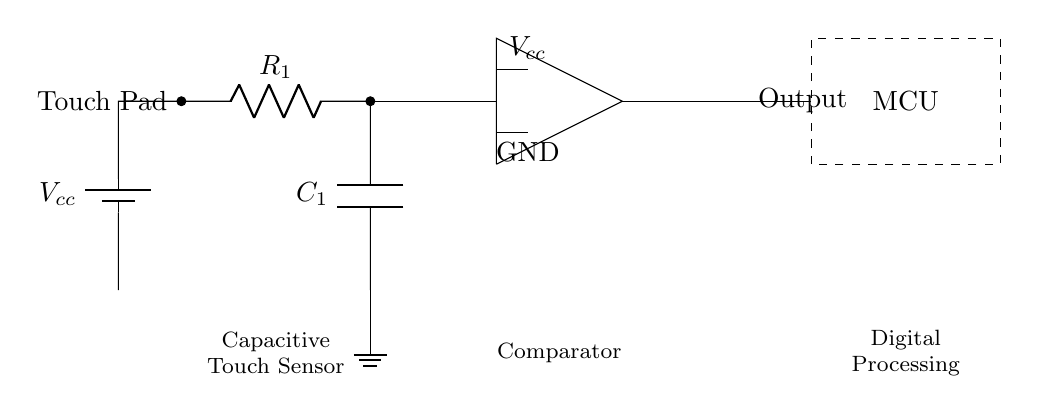What is the function of the touch pad? The touch pad acts as the input interface for the capacitive touch sensor, allowing users to interact with the digital book.
Answer: input interface What component is labeled as C1? C1 is a capacitor in the circuit, which is used to store electrical energy and help in sensing changes in capacitance when a finger comes close to the touch pad.
Answer: capacitor How many resistors are in this circuit? There is one resistor labeled R1 in the circuit, which is used to limit the flow of current.
Answer: one What is connected to the ground in the circuit? The ground is connected to the lower terminal of the capacitor C1 and is a common return path for electric current.
Answer: lower terminal of capacitor What does the numerical label on Vcc indicate? Vcc provides the necessary voltage supply for the circuit to function, indicated by its position and connection in the diagram.
Answer: voltage supply How does the capacitive touch sensor detect a touch? The sensor detects touch by measuring changes in capacitance at the touch pad, which occurs when a finger approaches the sensor, altering the electric field and enabling the op-amp to respond.
Answer: measuring capacitance changes What role does the microcontroller play in this circuit? The microcontroller processes the output signal from the touch sensor and converts it into meaningful data or commands for the interactive digital book interface.
Answer: processes output signal 